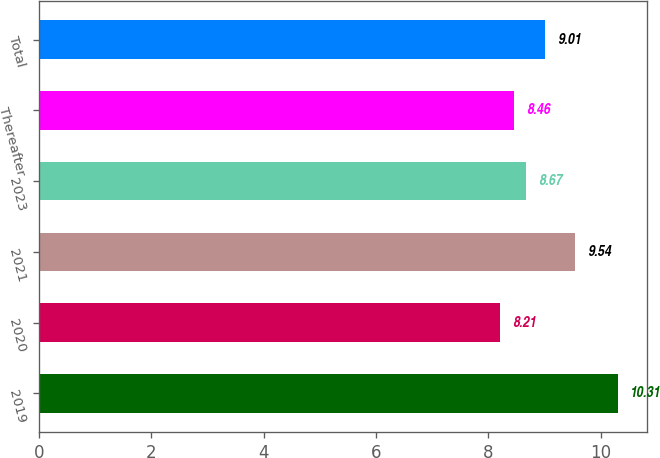Convert chart. <chart><loc_0><loc_0><loc_500><loc_500><bar_chart><fcel>2019<fcel>2020<fcel>2021<fcel>2023<fcel>Thereafter<fcel>Total<nl><fcel>10.31<fcel>8.21<fcel>9.54<fcel>8.67<fcel>8.46<fcel>9.01<nl></chart> 